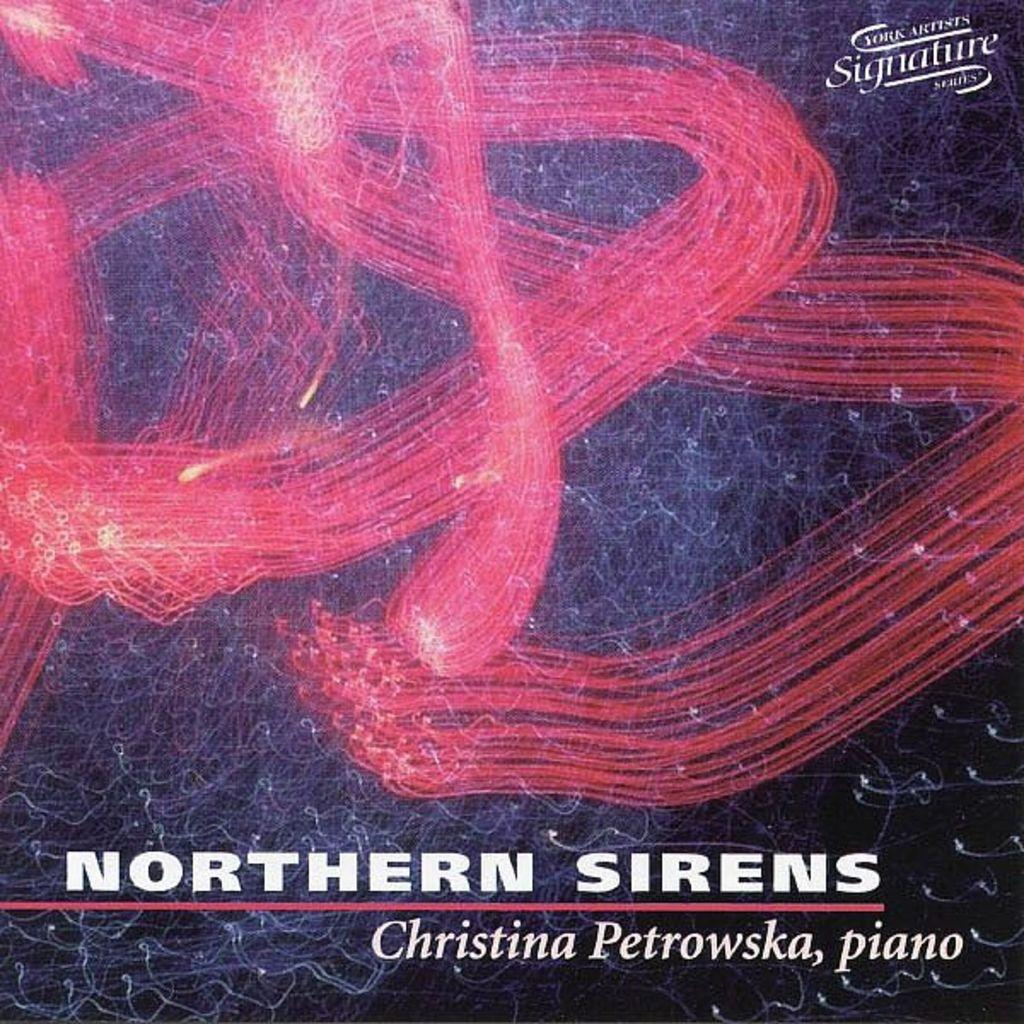What is the main object in the image? There is a poster in the image. What can be seen at the top of the poster? There are texts at the top of the image. What can be seen at the bottom of the poster? There are texts at the bottom of the image. What is in the middle of the poster? There is an image in the middle of the poster. How does the poster help the person reading it to stay current with the latest news? The poster does not provide any information about staying current with the latest news, as it only contains texts and an image. 